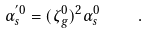Convert formula to latex. <formula><loc_0><loc_0><loc_500><loc_500>\alpha _ { s } ^ { ^ { \prime } 0 } = ( \zeta _ { g } ^ { 0 } ) ^ { 2 } \alpha _ { s } ^ { 0 } \quad \, .</formula> 